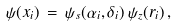<formula> <loc_0><loc_0><loc_500><loc_500>\psi ( { x } _ { i } ) \, = \, \psi _ { s } ( \alpha _ { i } , \delta _ { i } ) \, \psi _ { z } ( r _ { i } ) \, ,</formula> 